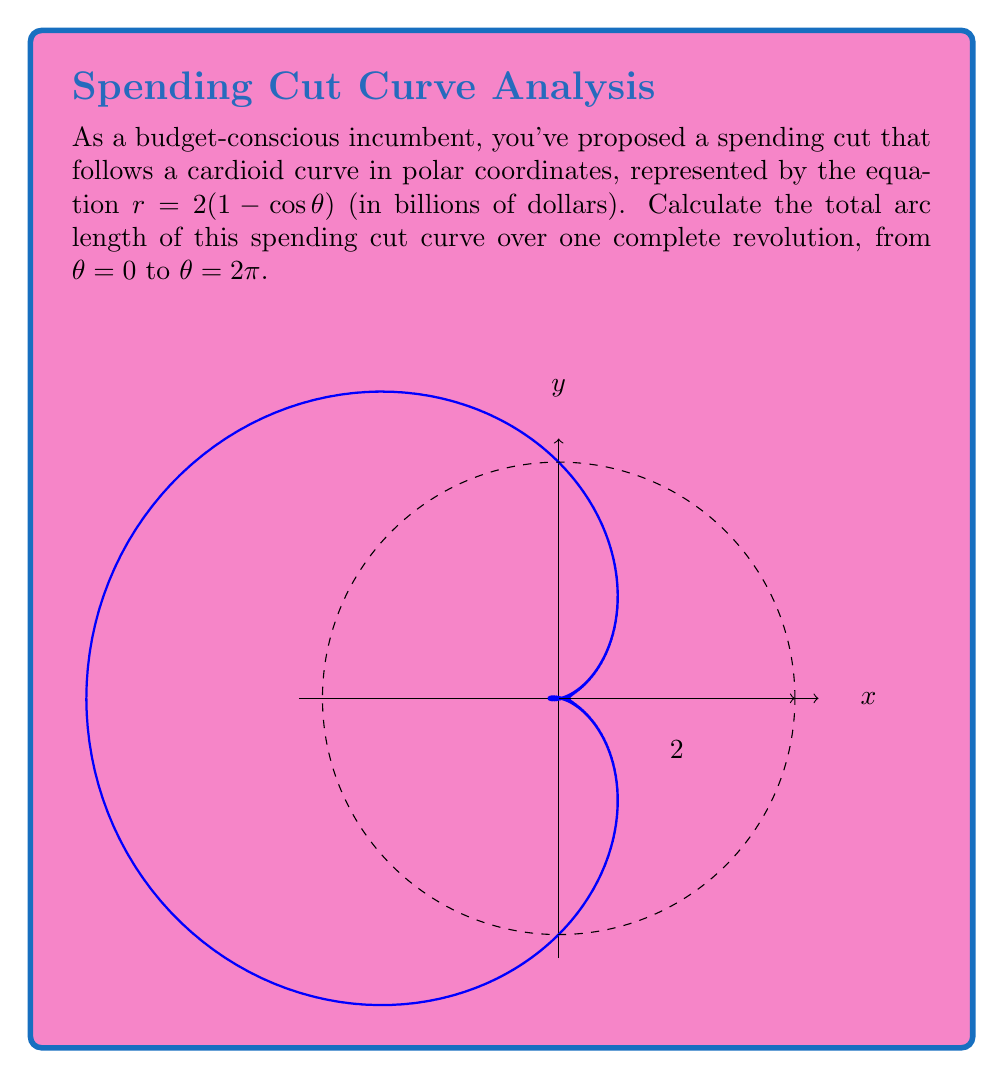Could you help me with this problem? To find the arc length of a polar curve, we use the formula:

$$ L = \int_a^b \sqrt{r^2 + \left(\frac{dr}{d\theta}\right)^2} d\theta $$

For our curve $r = 2(1 - \cos \theta)$, we need to:

1) Find $\frac{dr}{d\theta}$:
   $\frac{dr}{d\theta} = 2 \sin \theta$

2) Calculate $r^2 + \left(\frac{dr}{d\theta}\right)^2$:
   $r^2 + \left(\frac{dr}{d\theta}\right)^2 = [2(1 - \cos \theta)]^2 + (2 \sin \theta)^2$
   $= 4(1 - 2\cos \theta + \cos^2 \theta) + 4\sin^2 \theta$
   $= 4(1 - 2\cos \theta + \cos^2 \theta + \sin^2 \theta)$
   $= 4(2 - 2\cos \theta)$ (using $\sin^2 \theta + \cos^2 \theta = 1$)
   $= 8(1 - \cos \theta)$

3) Substitute into the integral:
   $$ L = \int_0^{2\pi} \sqrt{8(1 - \cos \theta)} d\theta $$
   $$ = 2\sqrt{2} \int_0^{2\pi} \sqrt{1 - \cos \theta} d\theta $$

4) Use the trigonometric identity $1 - \cos \theta = 2\sin^2 (\frac{\theta}{2})$:
   $$ L = 2\sqrt{2} \int_0^{2\pi} \sqrt{2\sin^2 (\frac{\theta}{2})} d\theta $$
   $$ = 4 \int_0^{2\pi} |\sin (\frac{\theta}{2})| d\theta $$

5) Evaluate the integral:
   $$ L = 4 \cdot 4 = 16 $$

Thus, the total arc length of the spending cut curve is 16 billion dollars.
Answer: $16$ billion dollars 